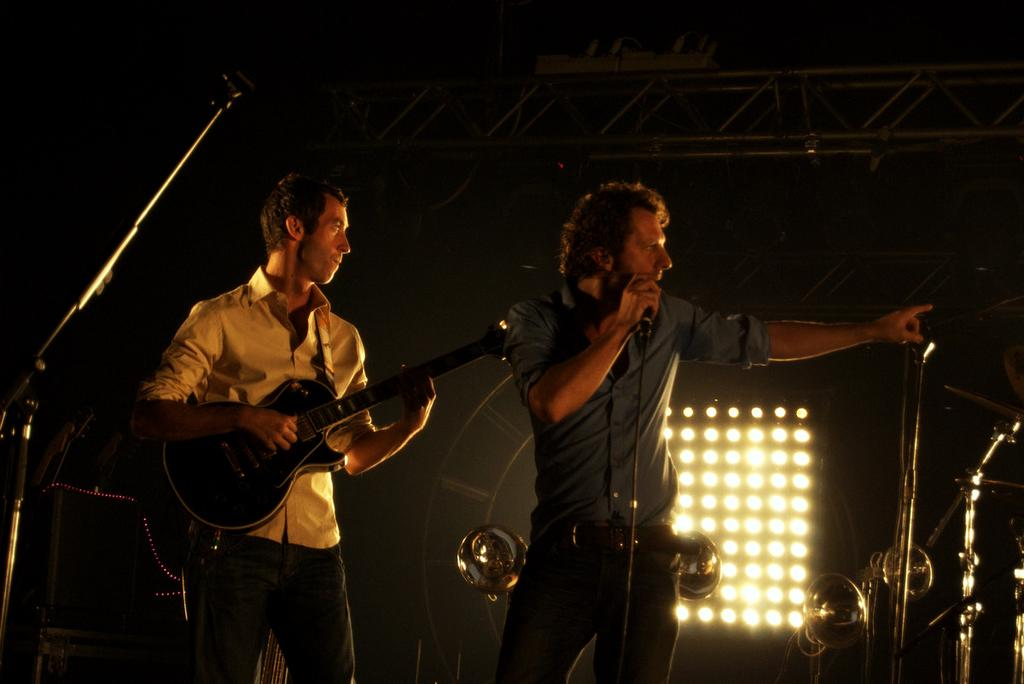How many men are present in the image? There are two men in the image. What are the men holding in their hands? One man is holding a microphone, and the other man is holding a guitar. What can be seen in the background of the image? There are additional microphones and lights in the background. What type of pear is being used as a sound amplifier in the image? There is no pear present in the image, and no pear is being used as a sound amplifier. 